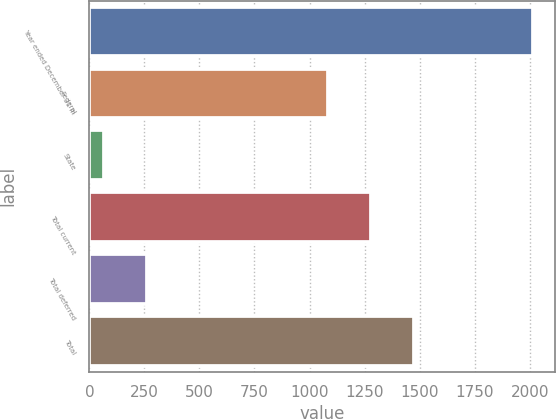<chart> <loc_0><loc_0><loc_500><loc_500><bar_chart><fcel>Year ended December 31 In<fcel>Federal<fcel>State<fcel>Total current<fcel>Total deferred<fcel>Total<nl><fcel>2014<fcel>1084<fcel>68<fcel>1278.6<fcel>262.6<fcel>1473.2<nl></chart> 